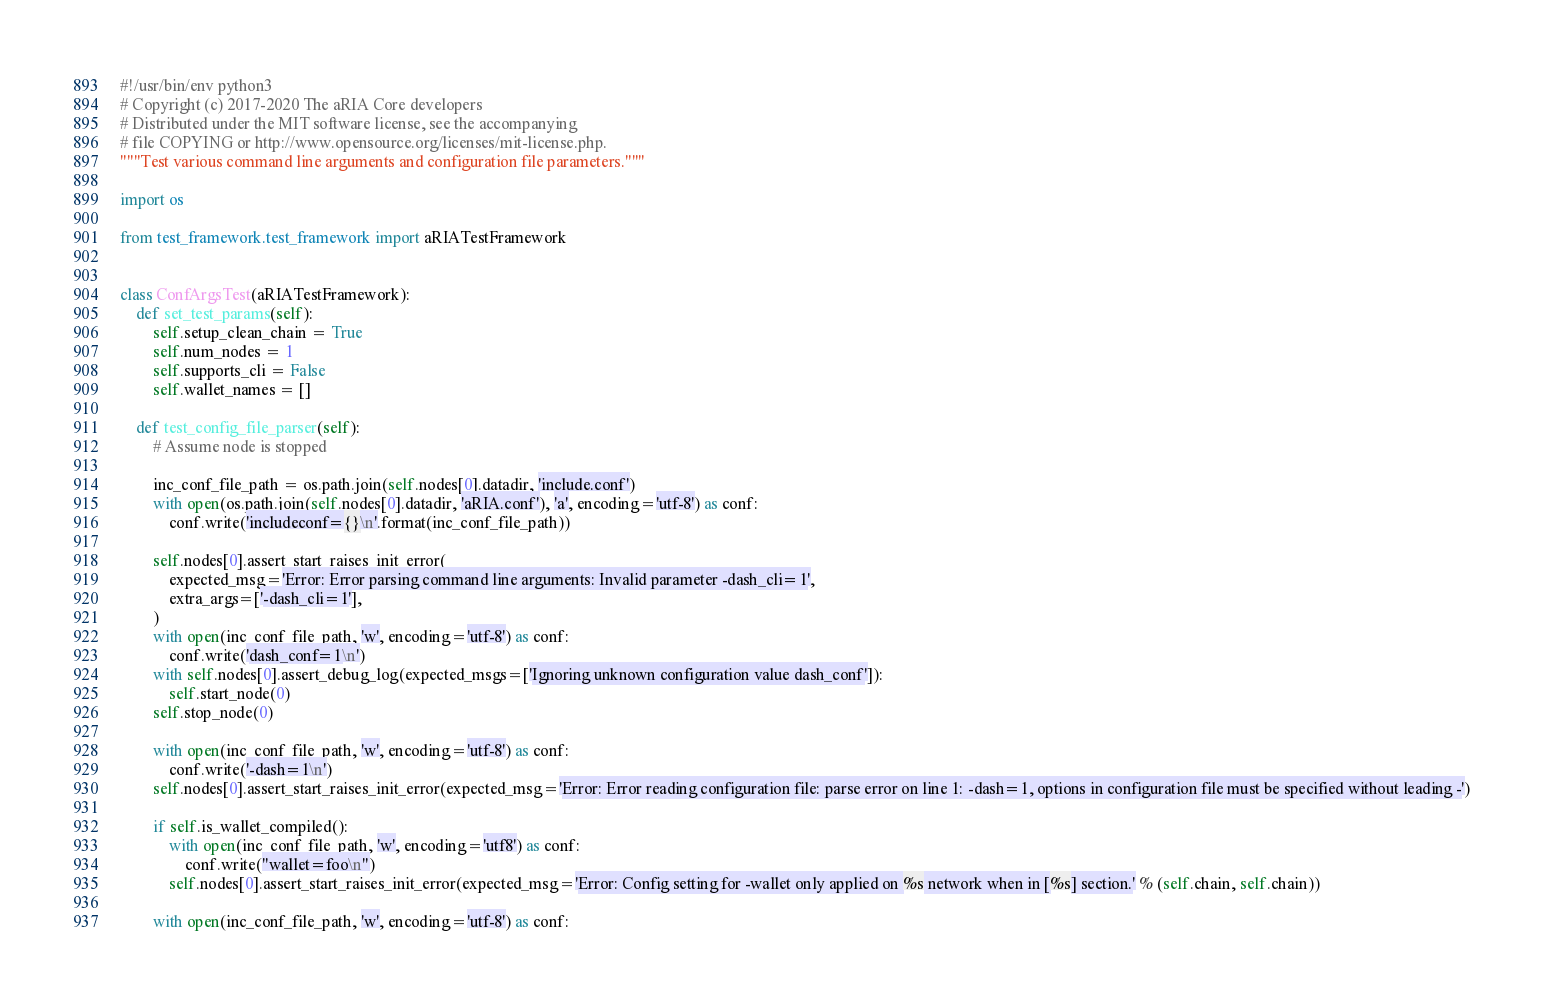<code> <loc_0><loc_0><loc_500><loc_500><_Python_>#!/usr/bin/env python3
# Copyright (c) 2017-2020 The aRIA Core developers
# Distributed under the MIT software license, see the accompanying
# file COPYING or http://www.opensource.org/licenses/mit-license.php.
"""Test various command line arguments and configuration file parameters."""

import os

from test_framework.test_framework import aRIATestFramework


class ConfArgsTest(aRIATestFramework):
    def set_test_params(self):
        self.setup_clean_chain = True
        self.num_nodes = 1
        self.supports_cli = False
        self.wallet_names = []

    def test_config_file_parser(self):
        # Assume node is stopped

        inc_conf_file_path = os.path.join(self.nodes[0].datadir, 'include.conf')
        with open(os.path.join(self.nodes[0].datadir, 'aRIA.conf'), 'a', encoding='utf-8') as conf:
            conf.write('includeconf={}\n'.format(inc_conf_file_path))

        self.nodes[0].assert_start_raises_init_error(
            expected_msg='Error: Error parsing command line arguments: Invalid parameter -dash_cli=1',
            extra_args=['-dash_cli=1'],
        )
        with open(inc_conf_file_path, 'w', encoding='utf-8') as conf:
            conf.write('dash_conf=1\n')
        with self.nodes[0].assert_debug_log(expected_msgs=['Ignoring unknown configuration value dash_conf']):
            self.start_node(0)
        self.stop_node(0)

        with open(inc_conf_file_path, 'w', encoding='utf-8') as conf:
            conf.write('-dash=1\n')
        self.nodes[0].assert_start_raises_init_error(expected_msg='Error: Error reading configuration file: parse error on line 1: -dash=1, options in configuration file must be specified without leading -')

        if self.is_wallet_compiled():
            with open(inc_conf_file_path, 'w', encoding='utf8') as conf:
                conf.write("wallet=foo\n")
            self.nodes[0].assert_start_raises_init_error(expected_msg='Error: Config setting for -wallet only applied on %s network when in [%s] section.' % (self.chain, self.chain))

        with open(inc_conf_file_path, 'w', encoding='utf-8') as conf:</code> 